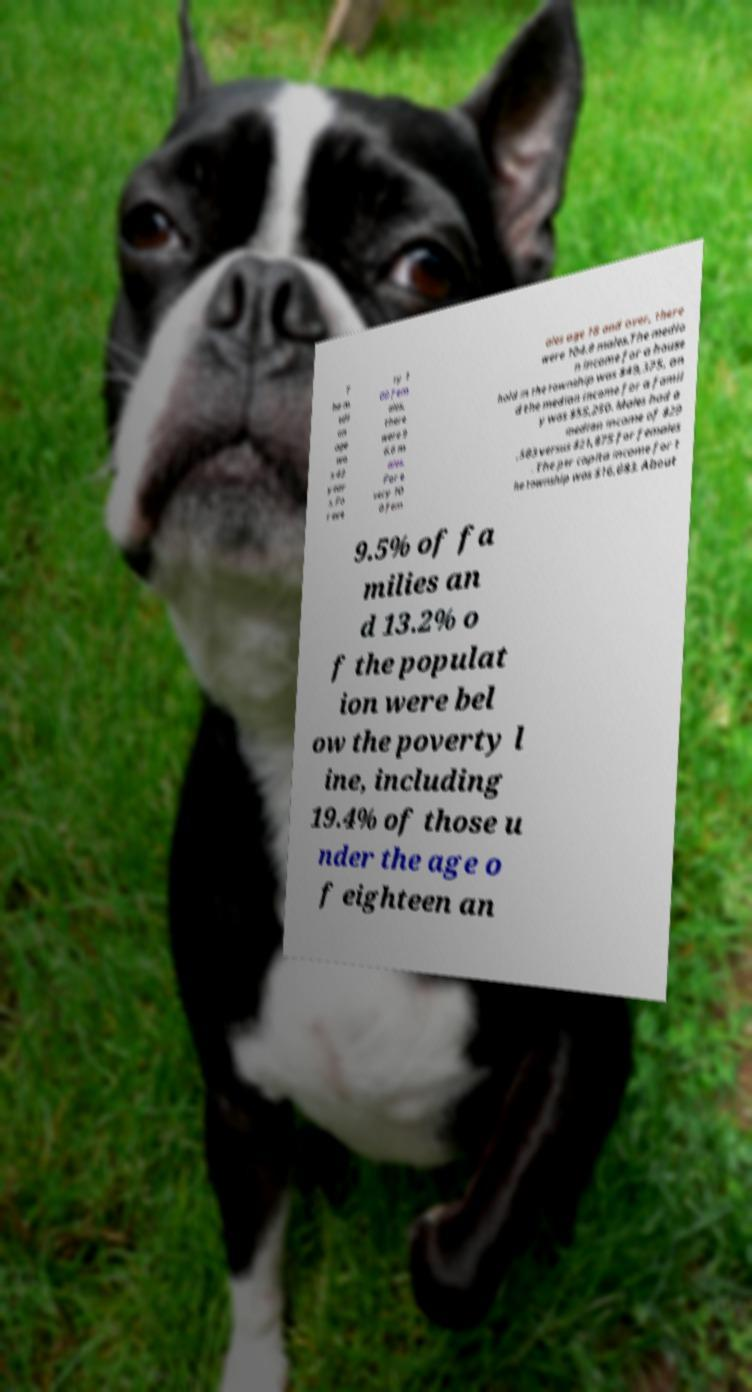Could you extract and type out the text from this image? T he m edi an age wa s 43 year s. Fo r eve ry 1 00 fem ales, there were 9 6.6 m ales. For e very 10 0 fem ales age 18 and over, there were 104.8 males.The media n income for a house hold in the township was $49,375, an d the median income for a famil y was $55,250. Males had a median income of $29 ,583 versus $21,875 for females . The per capita income for t he township was $16,683. About 9.5% of fa milies an d 13.2% o f the populat ion were bel ow the poverty l ine, including 19.4% of those u nder the age o f eighteen an 